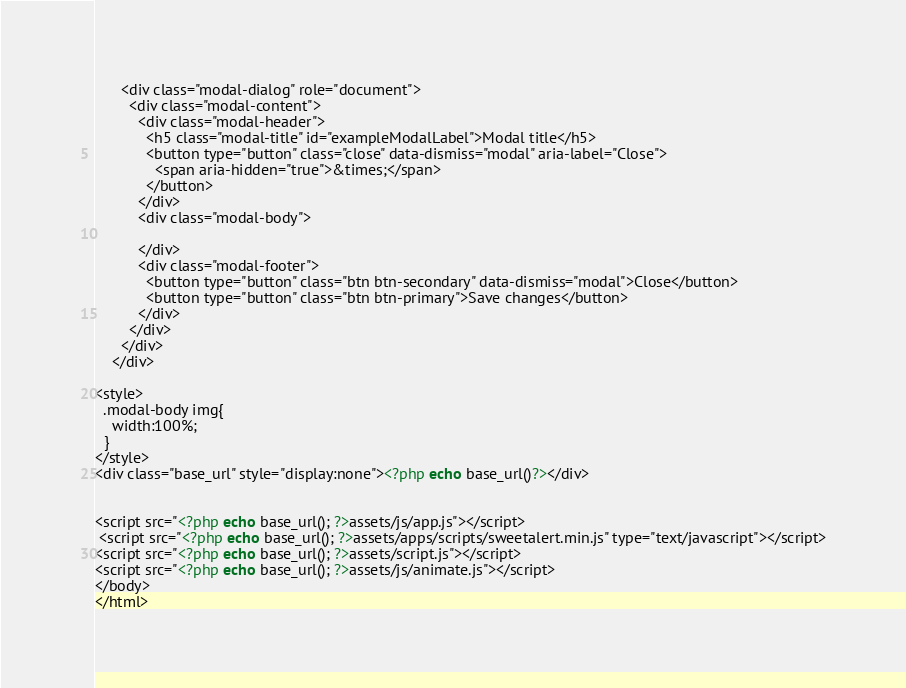Convert code to text. <code><loc_0><loc_0><loc_500><loc_500><_PHP_>      <div class="modal-dialog" role="document">
        <div class="modal-content">
          <div class="modal-header">
            <h5 class="modal-title" id="exampleModalLabel">Modal title</h5>
            <button type="button" class="close" data-dismiss="modal" aria-label="Close">
              <span aria-hidden="true">&times;</span>
            </button>
          </div>
          <div class="modal-body">

          </div>
          <div class="modal-footer">
            <button type="button" class="btn btn-secondary" data-dismiss="modal">Close</button>
            <button type="button" class="btn btn-primary">Save changes</button>
          </div>
        </div>
      </div>
    </div>

<style>
  .modal-body img{
    width:100%;
  }
</style>
<div class="base_url" style="display:none"><?php echo base_url()?></div>


<script src="<?php echo base_url(); ?>assets/js/app.js"></script>
 <script src="<?php echo base_url(); ?>assets/apps/scripts/sweetalert.min.js" type="text/javascript"></script>
<script src="<?php echo base_url(); ?>assets/script.js"></script>
<script src="<?php echo base_url(); ?>assets/js/animate.js"></script>
</body>
</html>
</code> 